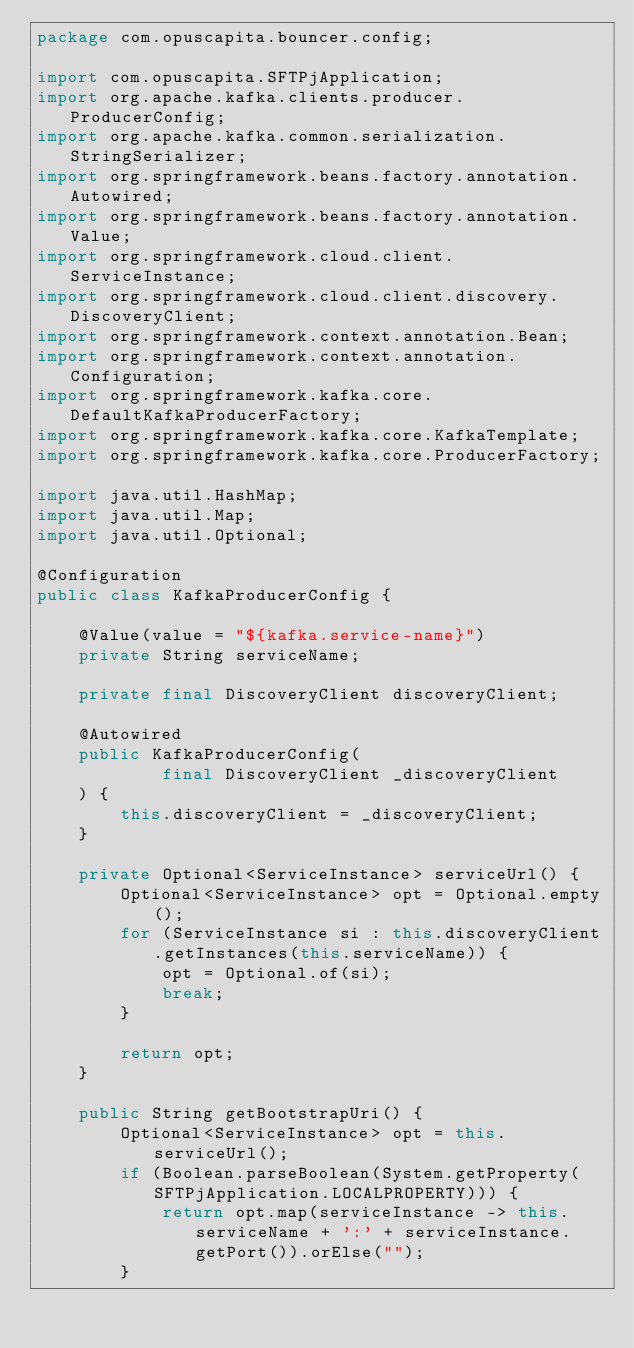Convert code to text. <code><loc_0><loc_0><loc_500><loc_500><_Java_>package com.opuscapita.bouncer.config;

import com.opuscapita.SFTPjApplication;
import org.apache.kafka.clients.producer.ProducerConfig;
import org.apache.kafka.common.serialization.StringSerializer;
import org.springframework.beans.factory.annotation.Autowired;
import org.springframework.beans.factory.annotation.Value;
import org.springframework.cloud.client.ServiceInstance;
import org.springframework.cloud.client.discovery.DiscoveryClient;
import org.springframework.context.annotation.Bean;
import org.springframework.context.annotation.Configuration;
import org.springframework.kafka.core.DefaultKafkaProducerFactory;
import org.springframework.kafka.core.KafkaTemplate;
import org.springframework.kafka.core.ProducerFactory;

import java.util.HashMap;
import java.util.Map;
import java.util.Optional;

@Configuration
public class KafkaProducerConfig {

    @Value(value = "${kafka.service-name}")
    private String serviceName;

    private final DiscoveryClient discoveryClient;

    @Autowired
    public KafkaProducerConfig(
            final DiscoveryClient _discoveryClient
    ) {
        this.discoveryClient = _discoveryClient;
    }

    private Optional<ServiceInstance> serviceUrl() {
        Optional<ServiceInstance> opt = Optional.empty();
        for (ServiceInstance si : this.discoveryClient.getInstances(this.serviceName)) {
            opt = Optional.of(si);
            break;
        }

        return opt;
    }

    public String getBootstrapUri() {
        Optional<ServiceInstance> opt = this.serviceUrl();
        if (Boolean.parseBoolean(System.getProperty(SFTPjApplication.LOCALPROPERTY))) {
            return opt.map(serviceInstance -> this.serviceName + ':' + serviceInstance.getPort()).orElse("");
        }</code> 